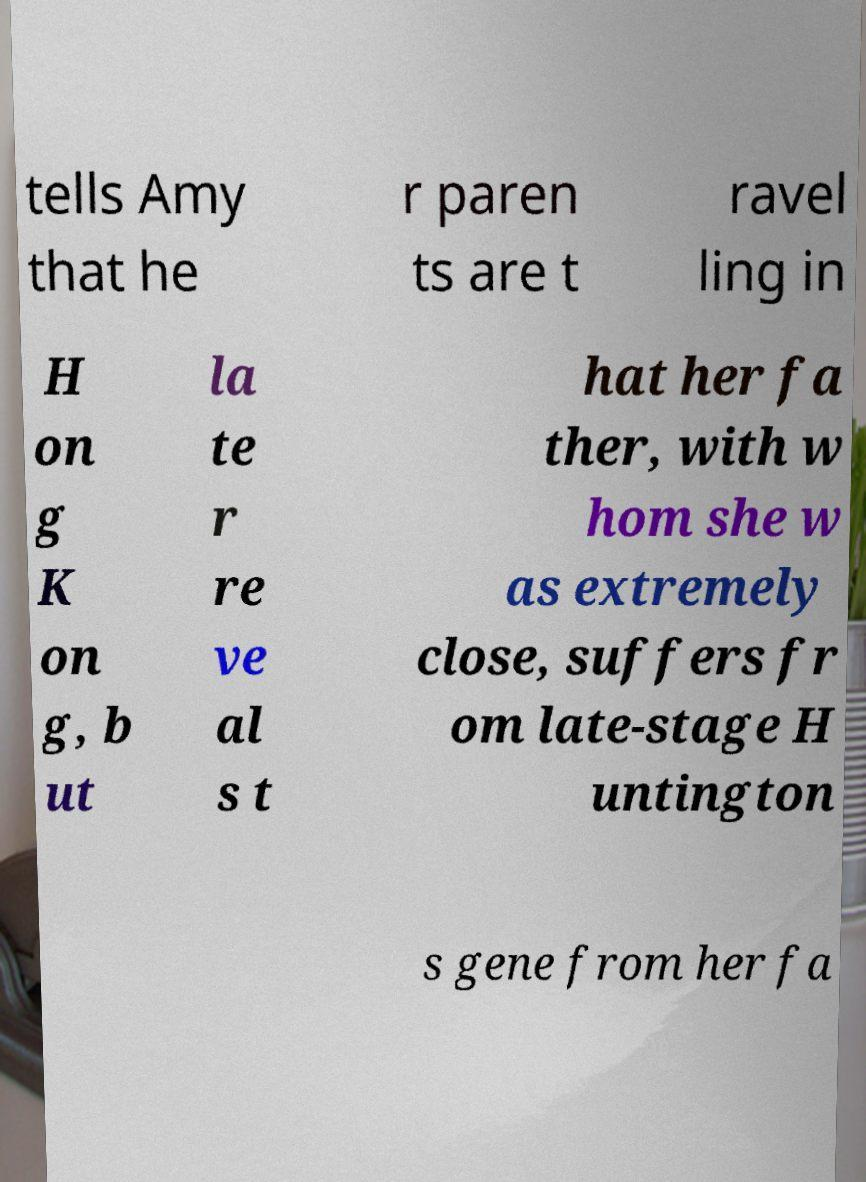Please identify and transcribe the text found in this image. tells Amy that he r paren ts are t ravel ling in H on g K on g, b ut la te r re ve al s t hat her fa ther, with w hom she w as extremely close, suffers fr om late-stage H untington s gene from her fa 